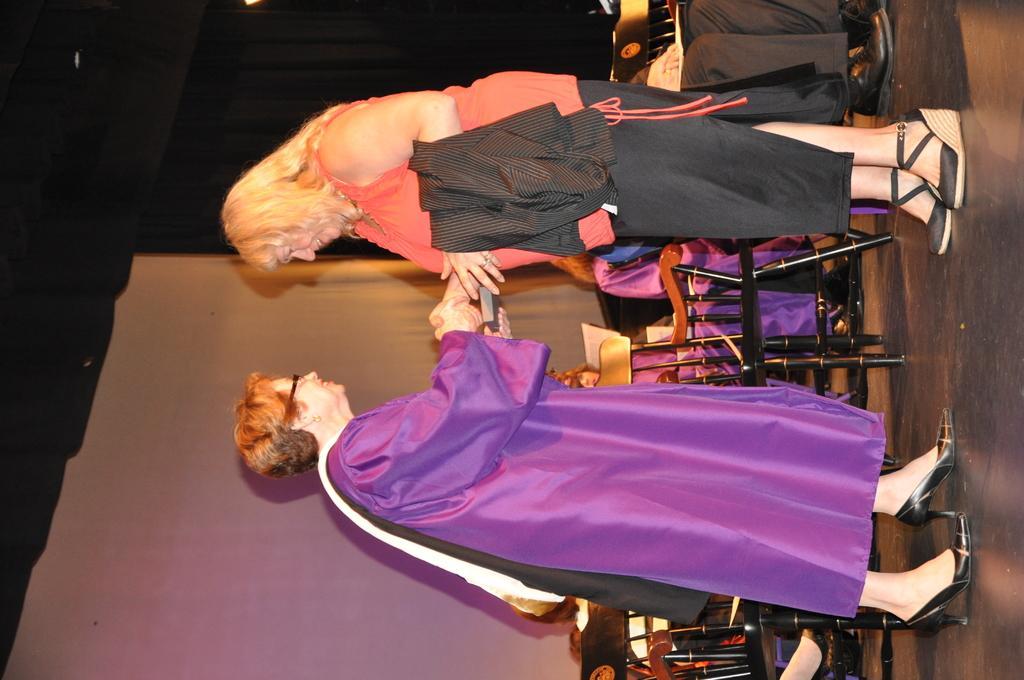Describe this image in one or two sentences. In this picture we can see two women are standing and smiling, in the background there are some people sitting on chairs, there is a dark background. 